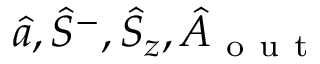<formula> <loc_0><loc_0><loc_500><loc_500>\hat { a } , \hat { S } ^ { - } , \hat { S } _ { z } , \hat { A } _ { o u t }</formula> 